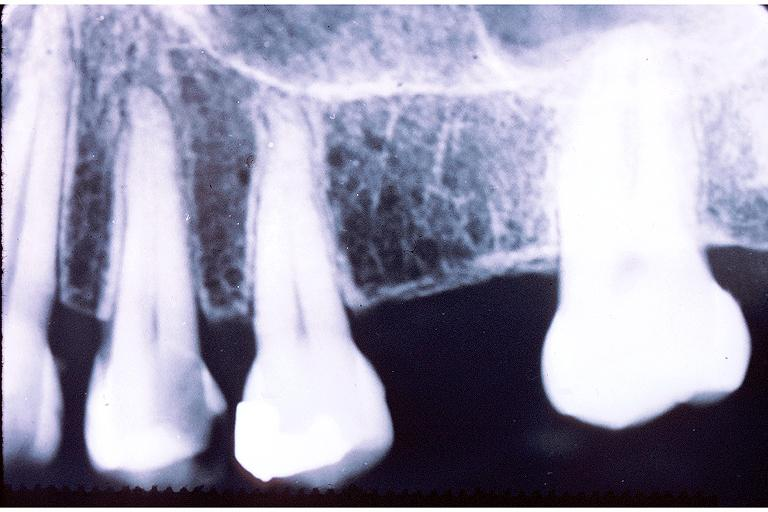does excellent example show caries?
Answer the question using a single word or phrase. No 